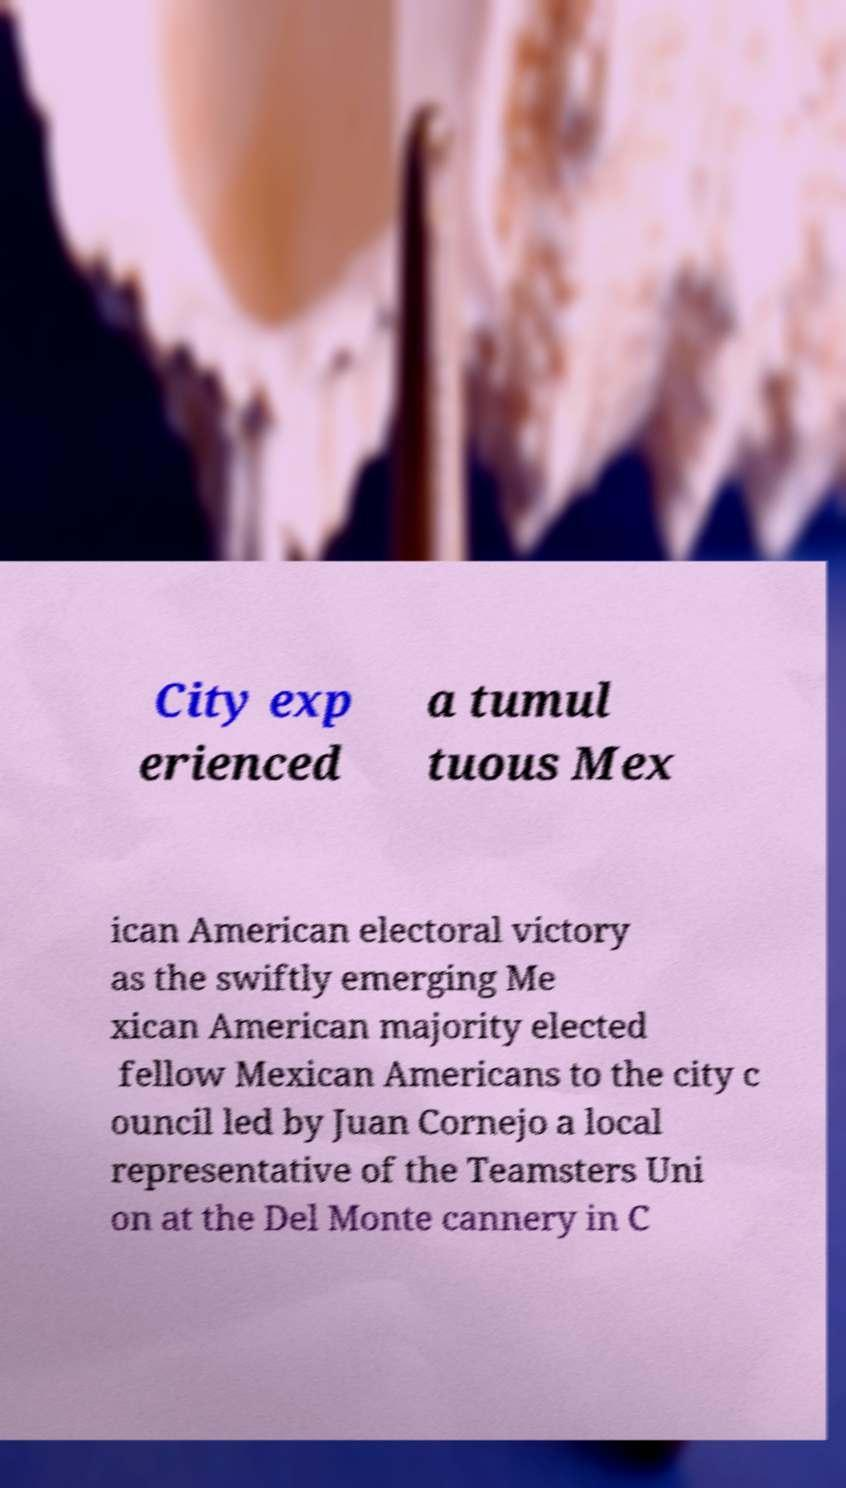Could you assist in decoding the text presented in this image and type it out clearly? City exp erienced a tumul tuous Mex ican American electoral victory as the swiftly emerging Me xican American majority elected fellow Mexican Americans to the city c ouncil led by Juan Cornejo a local representative of the Teamsters Uni on at the Del Monte cannery in C 